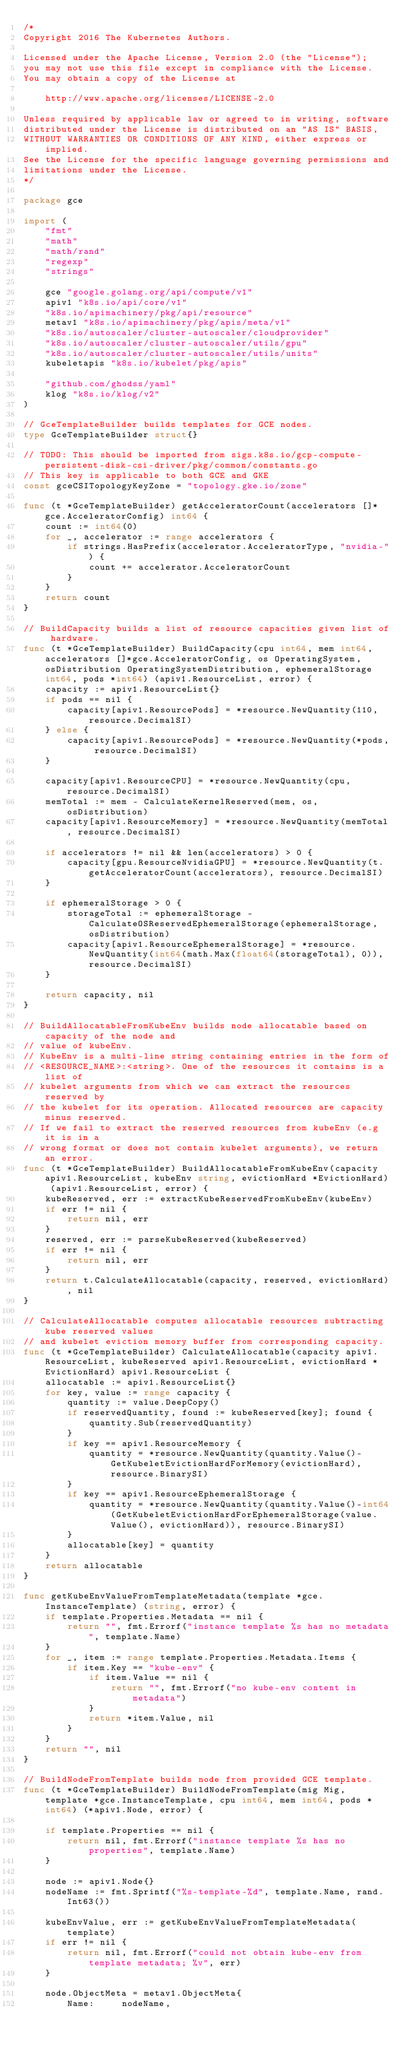<code> <loc_0><loc_0><loc_500><loc_500><_Go_>/*
Copyright 2016 The Kubernetes Authors.

Licensed under the Apache License, Version 2.0 (the "License");
you may not use this file except in compliance with the License.
You may obtain a copy of the License at

    http://www.apache.org/licenses/LICENSE-2.0

Unless required by applicable law or agreed to in writing, software
distributed under the License is distributed on an "AS IS" BASIS,
WITHOUT WARRANTIES OR CONDITIONS OF ANY KIND, either express or implied.
See the License for the specific language governing permissions and
limitations under the License.
*/

package gce

import (
	"fmt"
	"math"
	"math/rand"
	"regexp"
	"strings"

	gce "google.golang.org/api/compute/v1"
	apiv1 "k8s.io/api/core/v1"
	"k8s.io/apimachinery/pkg/api/resource"
	metav1 "k8s.io/apimachinery/pkg/apis/meta/v1"
	"k8s.io/autoscaler/cluster-autoscaler/cloudprovider"
	"k8s.io/autoscaler/cluster-autoscaler/utils/gpu"
	"k8s.io/autoscaler/cluster-autoscaler/utils/units"
	kubeletapis "k8s.io/kubelet/pkg/apis"

	"github.com/ghodss/yaml"
	klog "k8s.io/klog/v2"
)

// GceTemplateBuilder builds templates for GCE nodes.
type GceTemplateBuilder struct{}

// TODO: This should be imported from sigs.k8s.io/gcp-compute-persistent-disk-csi-driver/pkg/common/constants.go
// This key is applicable to both GCE and GKE
const gceCSITopologyKeyZone = "topology.gke.io/zone"

func (t *GceTemplateBuilder) getAcceleratorCount(accelerators []*gce.AcceleratorConfig) int64 {
	count := int64(0)
	for _, accelerator := range accelerators {
		if strings.HasPrefix(accelerator.AcceleratorType, "nvidia-") {
			count += accelerator.AcceleratorCount
		}
	}
	return count
}

// BuildCapacity builds a list of resource capacities given list of hardware.
func (t *GceTemplateBuilder) BuildCapacity(cpu int64, mem int64, accelerators []*gce.AcceleratorConfig, os OperatingSystem, osDistribution OperatingSystemDistribution, ephemeralStorage int64, pods *int64) (apiv1.ResourceList, error) {
	capacity := apiv1.ResourceList{}
	if pods == nil {
		capacity[apiv1.ResourcePods] = *resource.NewQuantity(110, resource.DecimalSI)
	} else {
		capacity[apiv1.ResourcePods] = *resource.NewQuantity(*pods, resource.DecimalSI)
	}

	capacity[apiv1.ResourceCPU] = *resource.NewQuantity(cpu, resource.DecimalSI)
	memTotal := mem - CalculateKernelReserved(mem, os, osDistribution)
	capacity[apiv1.ResourceMemory] = *resource.NewQuantity(memTotal, resource.DecimalSI)

	if accelerators != nil && len(accelerators) > 0 {
		capacity[gpu.ResourceNvidiaGPU] = *resource.NewQuantity(t.getAcceleratorCount(accelerators), resource.DecimalSI)
	}

	if ephemeralStorage > 0 {
		storageTotal := ephemeralStorage - CalculateOSReservedEphemeralStorage(ephemeralStorage, osDistribution)
		capacity[apiv1.ResourceEphemeralStorage] = *resource.NewQuantity(int64(math.Max(float64(storageTotal), 0)), resource.DecimalSI)
	}

	return capacity, nil
}

// BuildAllocatableFromKubeEnv builds node allocatable based on capacity of the node and
// value of kubeEnv.
// KubeEnv is a multi-line string containing entries in the form of
// <RESOURCE_NAME>:<string>. One of the resources it contains is a list of
// kubelet arguments from which we can extract the resources reserved by
// the kubelet for its operation. Allocated resources are capacity minus reserved.
// If we fail to extract the reserved resources from kubeEnv (e.g it is in a
// wrong format or does not contain kubelet arguments), we return an error.
func (t *GceTemplateBuilder) BuildAllocatableFromKubeEnv(capacity apiv1.ResourceList, kubeEnv string, evictionHard *EvictionHard) (apiv1.ResourceList, error) {
	kubeReserved, err := extractKubeReservedFromKubeEnv(kubeEnv)
	if err != nil {
		return nil, err
	}
	reserved, err := parseKubeReserved(kubeReserved)
	if err != nil {
		return nil, err
	}
	return t.CalculateAllocatable(capacity, reserved, evictionHard), nil
}

// CalculateAllocatable computes allocatable resources subtracting kube reserved values
// and kubelet eviction memory buffer from corresponding capacity.
func (t *GceTemplateBuilder) CalculateAllocatable(capacity apiv1.ResourceList, kubeReserved apiv1.ResourceList, evictionHard *EvictionHard) apiv1.ResourceList {
	allocatable := apiv1.ResourceList{}
	for key, value := range capacity {
		quantity := value.DeepCopy()
		if reservedQuantity, found := kubeReserved[key]; found {
			quantity.Sub(reservedQuantity)
		}
		if key == apiv1.ResourceMemory {
			quantity = *resource.NewQuantity(quantity.Value()-GetKubeletEvictionHardForMemory(evictionHard), resource.BinarySI)
		}
		if key == apiv1.ResourceEphemeralStorage {
			quantity = *resource.NewQuantity(quantity.Value()-int64(GetKubeletEvictionHardForEphemeralStorage(value.Value(), evictionHard)), resource.BinarySI)
		}
		allocatable[key] = quantity
	}
	return allocatable
}

func getKubeEnvValueFromTemplateMetadata(template *gce.InstanceTemplate) (string, error) {
	if template.Properties.Metadata == nil {
		return "", fmt.Errorf("instance template %s has no metadata", template.Name)
	}
	for _, item := range template.Properties.Metadata.Items {
		if item.Key == "kube-env" {
			if item.Value == nil {
				return "", fmt.Errorf("no kube-env content in metadata")
			}
			return *item.Value, nil
		}
	}
	return "", nil
}

// BuildNodeFromTemplate builds node from provided GCE template.
func (t *GceTemplateBuilder) BuildNodeFromTemplate(mig Mig, template *gce.InstanceTemplate, cpu int64, mem int64, pods *int64) (*apiv1.Node, error) {

	if template.Properties == nil {
		return nil, fmt.Errorf("instance template %s has no properties", template.Name)
	}

	node := apiv1.Node{}
	nodeName := fmt.Sprintf("%s-template-%d", template.Name, rand.Int63())

	kubeEnvValue, err := getKubeEnvValueFromTemplateMetadata(template)
	if err != nil {
		return nil, fmt.Errorf("could not obtain kube-env from template metadata; %v", err)
	}

	node.ObjectMeta = metav1.ObjectMeta{
		Name:     nodeName,</code> 